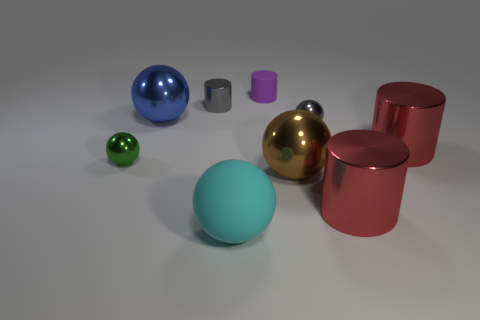What is the size of the gray metallic object that is the same shape as the green metallic object? The gray metallic object appears to be small, similar in size to the green object beside it which looks to be roughly the size of a standard drink can. 